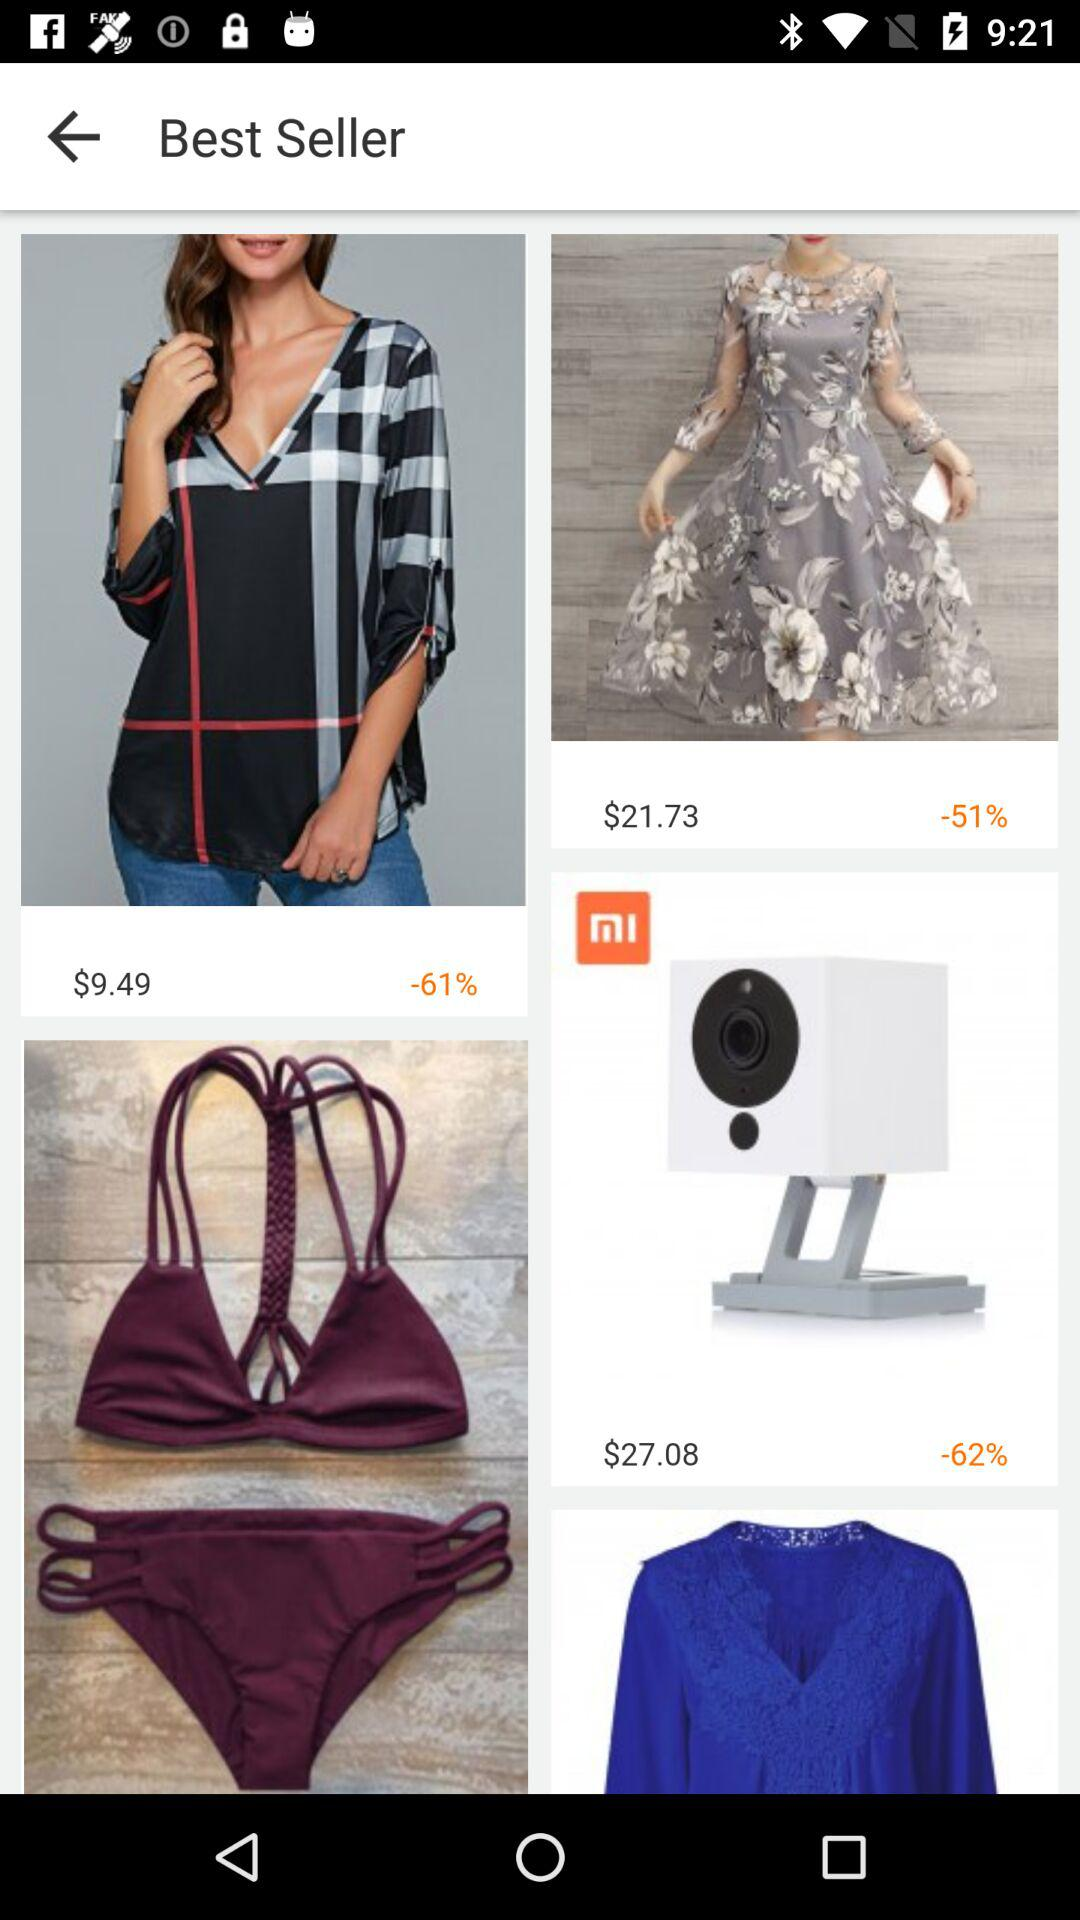What is the discount percentage on the top? The discount percentage on the top is 61. 